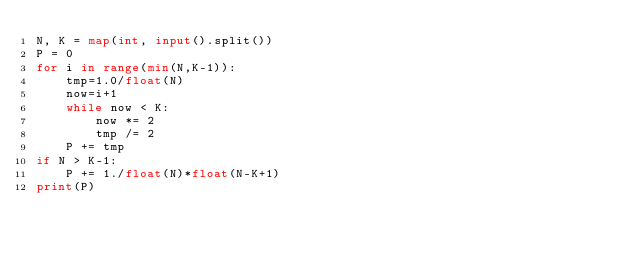<code> <loc_0><loc_0><loc_500><loc_500><_Python_>N, K = map(int, input().split())
P = 0
for i in range(min(N,K-1)):
    tmp=1.0/float(N)
    now=i+1
    while now < K:
        now *= 2
        tmp /= 2
    P += tmp
if N > K-1:
    P += 1./float(N)*float(N-K+1)
print(P)</code> 